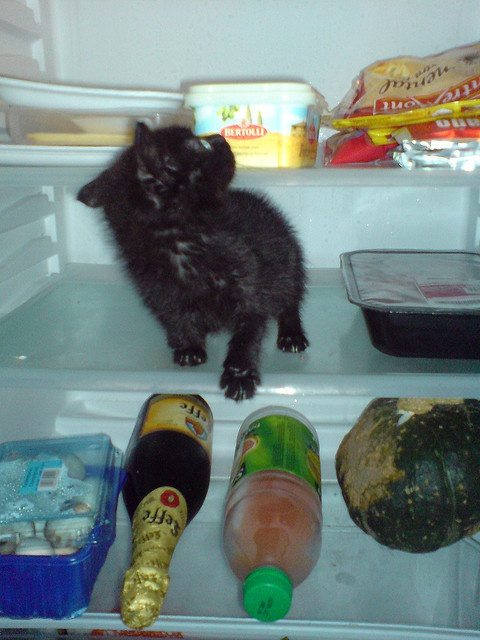Describe the objects in this image and their specific colors. I can see refrigerator in gray, black, lightblue, and darkgray tones, dog in darkgray, black, purple, and gray tones, cat in darkgray, black, and purple tones, bottle in darkgray, gray, olive, darkgreen, and green tones, and bottle in darkgray, black, olive, and gray tones in this image. 